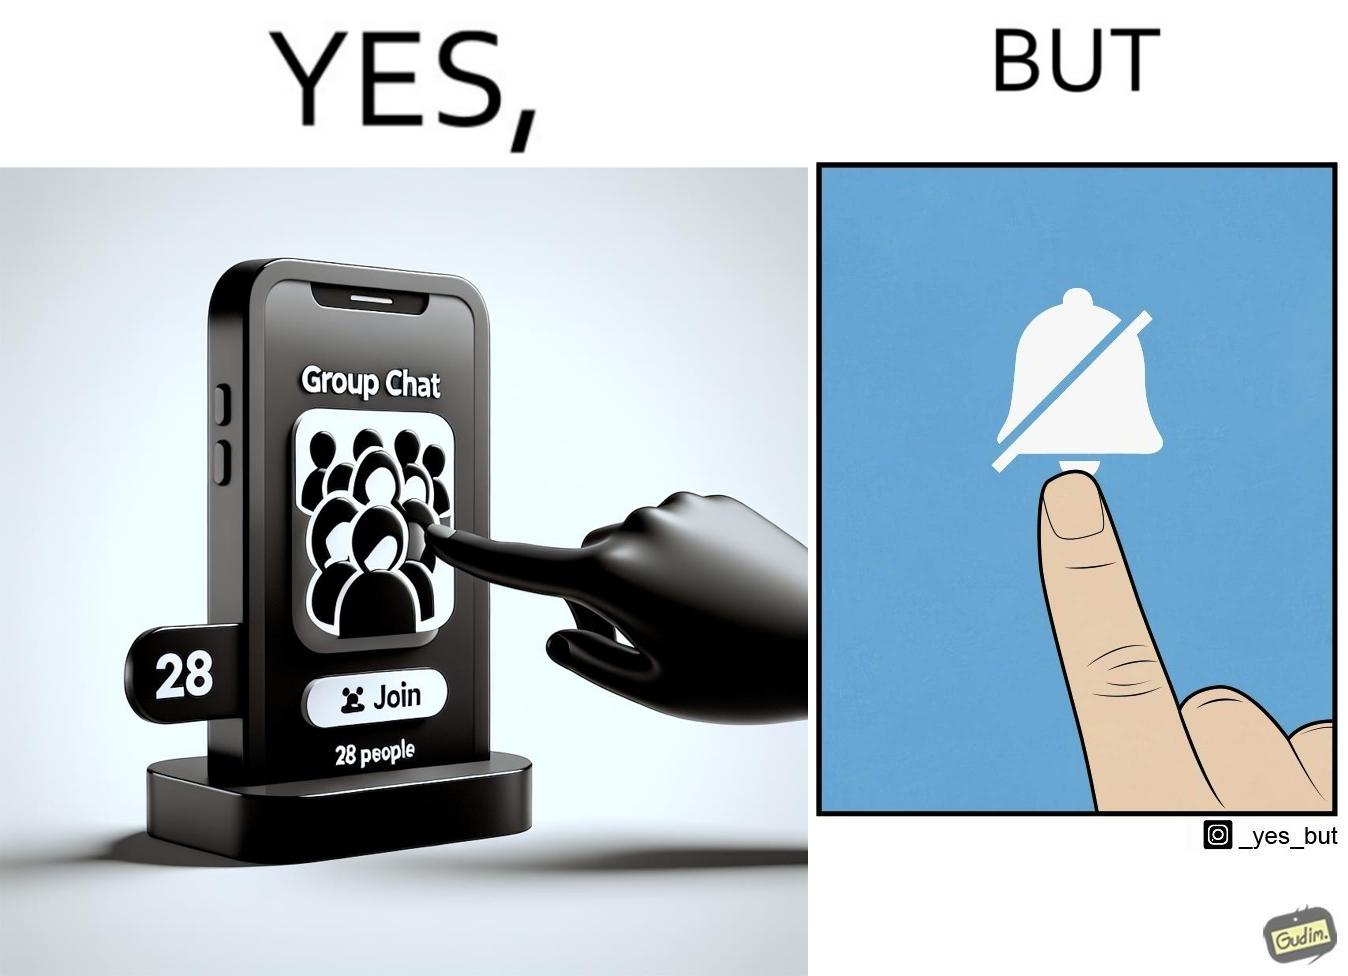Is this image satirical or non-satirical? Yes, this image is satirical. 